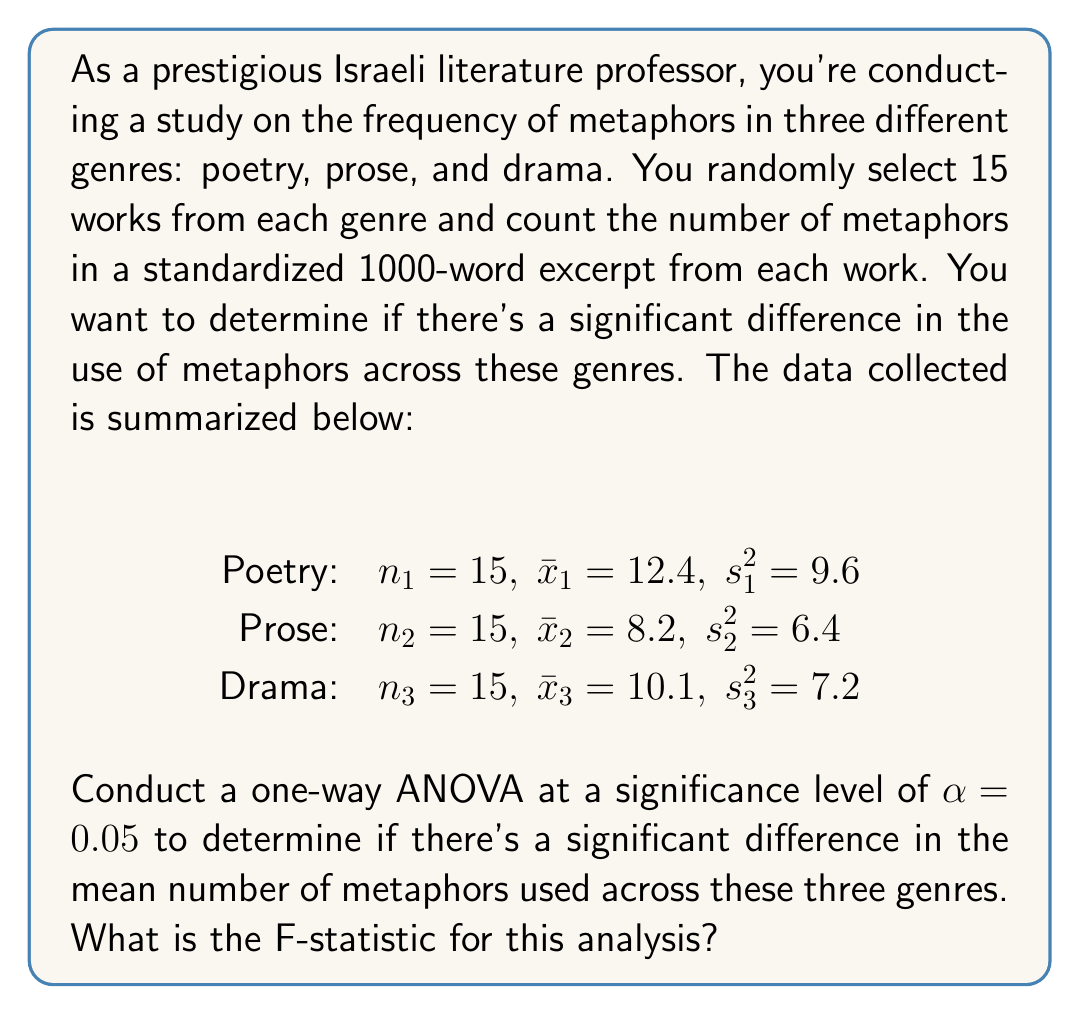Provide a solution to this math problem. To conduct a one-way ANOVA and calculate the F-statistic, we'll follow these steps:

1. Calculate the total sum of squares (SST):
   $$SST = \sum_{i=1}^k n_i(s_i^2 + \bar{x}_i^2) - \frac{(\sum_{i=1}^k n_i\bar{x}_i)^2}{\sum_{i=1}^k n_i}$$

   Where k is the number of groups (3 in this case).

   $$SST = 15(9.6 + 12.4^2) + 15(6.4 + 8.2^2) + 15(7.2 + 10.1^2) - \frac{(15 \cdot 12.4 + 15 \cdot 8.2 + 15 \cdot 10.1)^2}{45}$$
   $$SST = 15(163.52) + 15(73.64) + 15(109.21) - \frac{(186 + 123 + 151.5)^2}{45}$$
   $$SST = 2452.8 + 1104.6 + 1638.15 - \frac{460.5^2}{45} = 5195.55 - 4712.025 = 483.525$$

2. Calculate the between-group sum of squares (SSB):
   $$SSB = \sum_{i=1}^k n_i(\bar{x}_i - \bar{x})^2$$

   Where $\bar{x}$ is the grand mean:
   $$\bar{x} = \frac{12.4 + 8.2 + 10.1}{3} = 10.23333$$

   $$SSB = 15(12.4 - 10.23333)^2 + 15(8.2 - 10.23333)^2 + 15(10.1 - 10.23333)^2$$
   $$SSB = 15(2.16667^2) + 15(-2.03333^2) + 15(-0.13333^2)$$
   $$SSB = 15(4.69444) + 15(4.13444) + 15(0.01778) = 70.4166 + 62.0166 + 0.2667 = 132.7$$

3. Calculate the within-group sum of squares (SSW):
   $$SSW = SST - SSB = 483.525 - 132.7 = 350.825$$

4. Calculate the degrees of freedom:
   Between-group df: $df_B = k - 1 = 3 - 1 = 2$
   Within-group df: $df_W = N - k = 45 - 3 = 42$

5. Calculate the mean square between (MSB) and mean square within (MSW):
   $$MSB = \frac{SSB}{df_B} = \frac{132.7}{2} = 66.35$$
   $$MSW = \frac{SSW}{df_W} = \frac{350.825}{42} = 8.35536$$

6. Calculate the F-statistic:
   $$F = \frac{MSB}{MSW} = \frac{66.35}{8.35536} = 7.94$$
Answer: The F-statistic for this analysis is 7.94. 